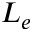<formula> <loc_0><loc_0><loc_500><loc_500>L _ { e }</formula> 